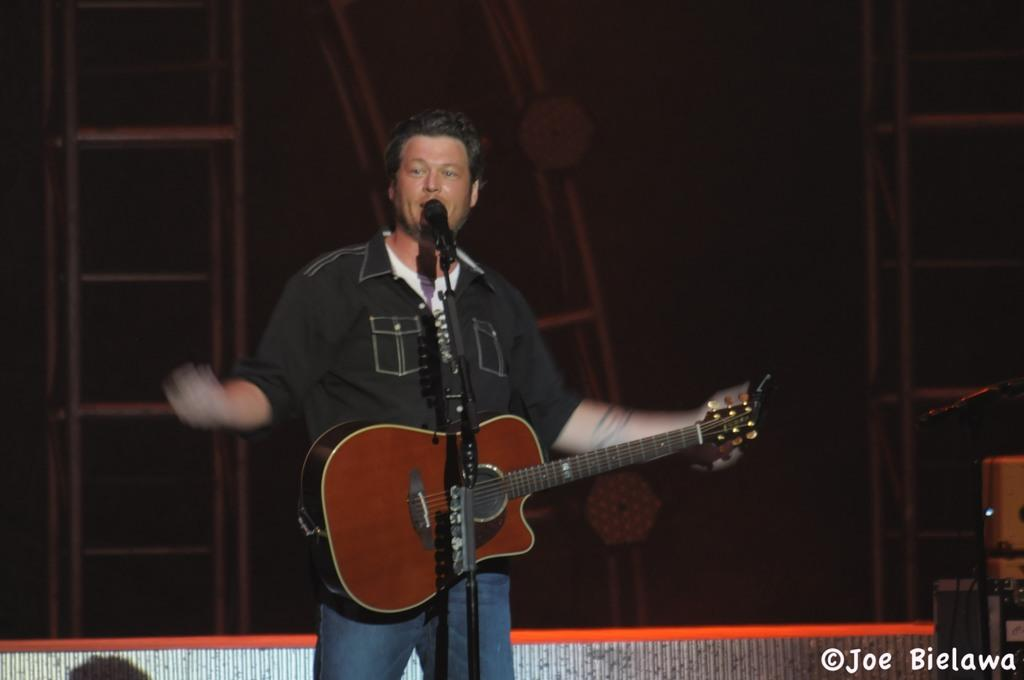Who is present in the image? There is a man in the image. What is the man doing in the image? The man is standing and holding a guitar. What object is in front of the man? There is a microphone stand in front of the man. Where does the scene appear to be taking place? The scene appears to be on a stage. What color is the crayon being used by the crowd in the image? There is no crayon or crowd present in the image; it features a man standing on a stage with a guitar and a microphone stand. 